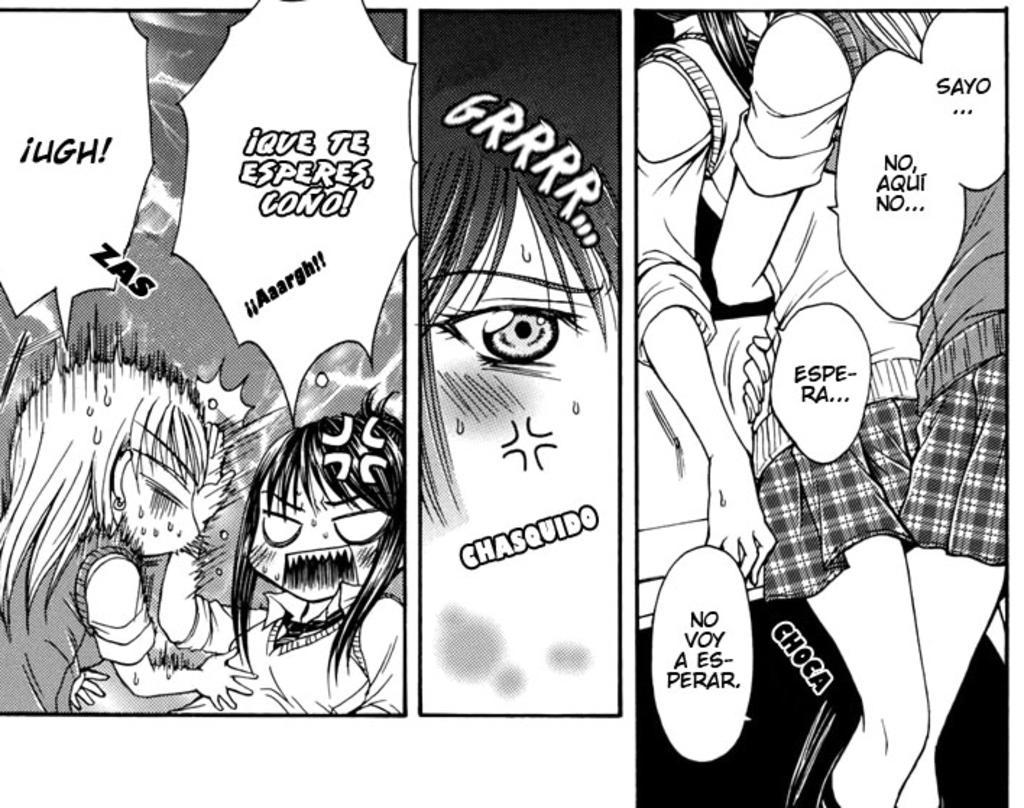Can you describe this image briefly? This is a black and white animated picture. In this image something is written. 